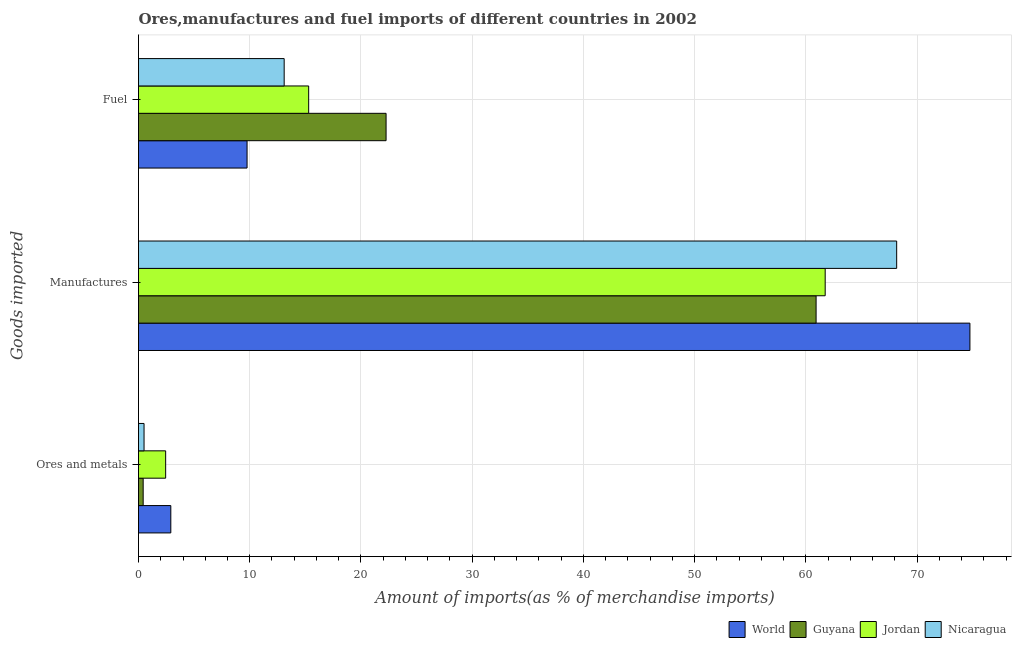How many different coloured bars are there?
Give a very brief answer. 4. How many groups of bars are there?
Your response must be concise. 3. Are the number of bars on each tick of the Y-axis equal?
Provide a short and direct response. Yes. How many bars are there on the 1st tick from the top?
Your answer should be compact. 4. What is the label of the 2nd group of bars from the top?
Give a very brief answer. Manufactures. What is the percentage of fuel imports in Guyana?
Your response must be concise. 22.26. Across all countries, what is the maximum percentage of fuel imports?
Make the answer very short. 22.26. Across all countries, what is the minimum percentage of ores and metals imports?
Provide a succinct answer. 0.42. In which country was the percentage of fuel imports maximum?
Offer a terse response. Guyana. In which country was the percentage of ores and metals imports minimum?
Ensure brevity in your answer.  Guyana. What is the total percentage of manufactures imports in the graph?
Make the answer very short. 265.57. What is the difference between the percentage of fuel imports in Jordan and that in Guyana?
Provide a succinct answer. -6.96. What is the difference between the percentage of ores and metals imports in Jordan and the percentage of manufactures imports in Nicaragua?
Provide a short and direct response. -65.72. What is the average percentage of ores and metals imports per country?
Your answer should be very brief. 1.57. What is the difference between the percentage of manufactures imports and percentage of ores and metals imports in World?
Make the answer very short. 71.85. What is the ratio of the percentage of fuel imports in Nicaragua to that in Jordan?
Provide a short and direct response. 0.86. Is the difference between the percentage of ores and metals imports in World and Guyana greater than the difference between the percentage of fuel imports in World and Guyana?
Provide a succinct answer. Yes. What is the difference between the highest and the second highest percentage of manufactures imports?
Provide a succinct answer. 6.59. What is the difference between the highest and the lowest percentage of manufactures imports?
Make the answer very short. 13.83. Is the sum of the percentage of fuel imports in World and Guyana greater than the maximum percentage of ores and metals imports across all countries?
Make the answer very short. Yes. What does the 2nd bar from the top in Ores and metals represents?
Your answer should be very brief. Jordan. What does the 3rd bar from the bottom in Manufactures represents?
Give a very brief answer. Jordan. Does the graph contain any zero values?
Make the answer very short. No. Does the graph contain grids?
Keep it short and to the point. Yes. Where does the legend appear in the graph?
Your response must be concise. Bottom right. How many legend labels are there?
Your answer should be very brief. 4. How are the legend labels stacked?
Your answer should be compact. Horizontal. What is the title of the graph?
Offer a very short reply. Ores,manufactures and fuel imports of different countries in 2002. Does "Timor-Leste" appear as one of the legend labels in the graph?
Your response must be concise. No. What is the label or title of the X-axis?
Provide a short and direct response. Amount of imports(as % of merchandise imports). What is the label or title of the Y-axis?
Your answer should be very brief. Goods imported. What is the Amount of imports(as % of merchandise imports) in World in Ores and metals?
Give a very brief answer. 2.9. What is the Amount of imports(as % of merchandise imports) of Guyana in Ores and metals?
Your answer should be very brief. 0.42. What is the Amount of imports(as % of merchandise imports) in Jordan in Ores and metals?
Ensure brevity in your answer.  2.44. What is the Amount of imports(as % of merchandise imports) of Nicaragua in Ores and metals?
Ensure brevity in your answer.  0.5. What is the Amount of imports(as % of merchandise imports) in World in Manufactures?
Give a very brief answer. 74.75. What is the Amount of imports(as % of merchandise imports) of Guyana in Manufactures?
Provide a succinct answer. 60.92. What is the Amount of imports(as % of merchandise imports) of Jordan in Manufactures?
Ensure brevity in your answer.  61.74. What is the Amount of imports(as % of merchandise imports) in Nicaragua in Manufactures?
Make the answer very short. 68.16. What is the Amount of imports(as % of merchandise imports) in World in Fuel?
Keep it short and to the point. 9.76. What is the Amount of imports(as % of merchandise imports) in Guyana in Fuel?
Keep it short and to the point. 22.26. What is the Amount of imports(as % of merchandise imports) of Jordan in Fuel?
Offer a very short reply. 15.3. What is the Amount of imports(as % of merchandise imports) in Nicaragua in Fuel?
Offer a very short reply. 13.1. Across all Goods imported, what is the maximum Amount of imports(as % of merchandise imports) in World?
Make the answer very short. 74.75. Across all Goods imported, what is the maximum Amount of imports(as % of merchandise imports) of Guyana?
Give a very brief answer. 60.92. Across all Goods imported, what is the maximum Amount of imports(as % of merchandise imports) in Jordan?
Offer a terse response. 61.74. Across all Goods imported, what is the maximum Amount of imports(as % of merchandise imports) in Nicaragua?
Your answer should be compact. 68.16. Across all Goods imported, what is the minimum Amount of imports(as % of merchandise imports) in World?
Keep it short and to the point. 2.9. Across all Goods imported, what is the minimum Amount of imports(as % of merchandise imports) of Guyana?
Provide a short and direct response. 0.42. Across all Goods imported, what is the minimum Amount of imports(as % of merchandise imports) of Jordan?
Offer a very short reply. 2.44. Across all Goods imported, what is the minimum Amount of imports(as % of merchandise imports) of Nicaragua?
Keep it short and to the point. 0.5. What is the total Amount of imports(as % of merchandise imports) of World in the graph?
Provide a short and direct response. 87.42. What is the total Amount of imports(as % of merchandise imports) of Guyana in the graph?
Give a very brief answer. 83.6. What is the total Amount of imports(as % of merchandise imports) of Jordan in the graph?
Your answer should be compact. 79.48. What is the total Amount of imports(as % of merchandise imports) of Nicaragua in the graph?
Your answer should be compact. 81.76. What is the difference between the Amount of imports(as % of merchandise imports) of World in Ores and metals and that in Manufactures?
Your answer should be compact. -71.85. What is the difference between the Amount of imports(as % of merchandise imports) of Guyana in Ores and metals and that in Manufactures?
Offer a terse response. -60.5. What is the difference between the Amount of imports(as % of merchandise imports) of Jordan in Ores and metals and that in Manufactures?
Offer a terse response. -59.3. What is the difference between the Amount of imports(as % of merchandise imports) in Nicaragua in Ores and metals and that in Manufactures?
Provide a short and direct response. -67.67. What is the difference between the Amount of imports(as % of merchandise imports) of World in Ores and metals and that in Fuel?
Keep it short and to the point. -6.86. What is the difference between the Amount of imports(as % of merchandise imports) of Guyana in Ores and metals and that in Fuel?
Ensure brevity in your answer.  -21.84. What is the difference between the Amount of imports(as % of merchandise imports) in Jordan in Ores and metals and that in Fuel?
Ensure brevity in your answer.  -12.86. What is the difference between the Amount of imports(as % of merchandise imports) of Nicaragua in Ores and metals and that in Fuel?
Offer a very short reply. -12.6. What is the difference between the Amount of imports(as % of merchandise imports) in World in Manufactures and that in Fuel?
Your response must be concise. 64.99. What is the difference between the Amount of imports(as % of merchandise imports) in Guyana in Manufactures and that in Fuel?
Offer a terse response. 38.66. What is the difference between the Amount of imports(as % of merchandise imports) in Jordan in Manufactures and that in Fuel?
Give a very brief answer. 46.44. What is the difference between the Amount of imports(as % of merchandise imports) of Nicaragua in Manufactures and that in Fuel?
Offer a very short reply. 55.07. What is the difference between the Amount of imports(as % of merchandise imports) in World in Ores and metals and the Amount of imports(as % of merchandise imports) in Guyana in Manufactures?
Provide a short and direct response. -58.02. What is the difference between the Amount of imports(as % of merchandise imports) in World in Ores and metals and the Amount of imports(as % of merchandise imports) in Jordan in Manufactures?
Your response must be concise. -58.83. What is the difference between the Amount of imports(as % of merchandise imports) of World in Ores and metals and the Amount of imports(as % of merchandise imports) of Nicaragua in Manufactures?
Your answer should be compact. -65.26. What is the difference between the Amount of imports(as % of merchandise imports) of Guyana in Ores and metals and the Amount of imports(as % of merchandise imports) of Jordan in Manufactures?
Offer a very short reply. -61.32. What is the difference between the Amount of imports(as % of merchandise imports) of Guyana in Ores and metals and the Amount of imports(as % of merchandise imports) of Nicaragua in Manufactures?
Provide a succinct answer. -67.75. What is the difference between the Amount of imports(as % of merchandise imports) of Jordan in Ores and metals and the Amount of imports(as % of merchandise imports) of Nicaragua in Manufactures?
Give a very brief answer. -65.72. What is the difference between the Amount of imports(as % of merchandise imports) of World in Ores and metals and the Amount of imports(as % of merchandise imports) of Guyana in Fuel?
Provide a short and direct response. -19.35. What is the difference between the Amount of imports(as % of merchandise imports) in World in Ores and metals and the Amount of imports(as % of merchandise imports) in Jordan in Fuel?
Offer a very short reply. -12.39. What is the difference between the Amount of imports(as % of merchandise imports) in World in Ores and metals and the Amount of imports(as % of merchandise imports) in Nicaragua in Fuel?
Offer a terse response. -10.19. What is the difference between the Amount of imports(as % of merchandise imports) in Guyana in Ores and metals and the Amount of imports(as % of merchandise imports) in Jordan in Fuel?
Provide a succinct answer. -14.88. What is the difference between the Amount of imports(as % of merchandise imports) of Guyana in Ores and metals and the Amount of imports(as % of merchandise imports) of Nicaragua in Fuel?
Your response must be concise. -12.68. What is the difference between the Amount of imports(as % of merchandise imports) of Jordan in Ores and metals and the Amount of imports(as % of merchandise imports) of Nicaragua in Fuel?
Provide a short and direct response. -10.66. What is the difference between the Amount of imports(as % of merchandise imports) of World in Manufactures and the Amount of imports(as % of merchandise imports) of Guyana in Fuel?
Provide a succinct answer. 52.49. What is the difference between the Amount of imports(as % of merchandise imports) in World in Manufactures and the Amount of imports(as % of merchandise imports) in Jordan in Fuel?
Provide a short and direct response. 59.45. What is the difference between the Amount of imports(as % of merchandise imports) of World in Manufactures and the Amount of imports(as % of merchandise imports) of Nicaragua in Fuel?
Your answer should be very brief. 61.65. What is the difference between the Amount of imports(as % of merchandise imports) in Guyana in Manufactures and the Amount of imports(as % of merchandise imports) in Jordan in Fuel?
Offer a very short reply. 45.62. What is the difference between the Amount of imports(as % of merchandise imports) of Guyana in Manufactures and the Amount of imports(as % of merchandise imports) of Nicaragua in Fuel?
Offer a very short reply. 47.82. What is the difference between the Amount of imports(as % of merchandise imports) of Jordan in Manufactures and the Amount of imports(as % of merchandise imports) of Nicaragua in Fuel?
Offer a very short reply. 48.64. What is the average Amount of imports(as % of merchandise imports) in World per Goods imported?
Your answer should be compact. 29.14. What is the average Amount of imports(as % of merchandise imports) of Guyana per Goods imported?
Offer a very short reply. 27.87. What is the average Amount of imports(as % of merchandise imports) in Jordan per Goods imported?
Provide a short and direct response. 26.49. What is the average Amount of imports(as % of merchandise imports) in Nicaragua per Goods imported?
Offer a very short reply. 27.25. What is the difference between the Amount of imports(as % of merchandise imports) of World and Amount of imports(as % of merchandise imports) of Guyana in Ores and metals?
Keep it short and to the point. 2.49. What is the difference between the Amount of imports(as % of merchandise imports) in World and Amount of imports(as % of merchandise imports) in Jordan in Ores and metals?
Provide a succinct answer. 0.46. What is the difference between the Amount of imports(as % of merchandise imports) of World and Amount of imports(as % of merchandise imports) of Nicaragua in Ores and metals?
Provide a succinct answer. 2.41. What is the difference between the Amount of imports(as % of merchandise imports) in Guyana and Amount of imports(as % of merchandise imports) in Jordan in Ores and metals?
Your answer should be very brief. -2.02. What is the difference between the Amount of imports(as % of merchandise imports) in Guyana and Amount of imports(as % of merchandise imports) in Nicaragua in Ores and metals?
Provide a short and direct response. -0.08. What is the difference between the Amount of imports(as % of merchandise imports) of Jordan and Amount of imports(as % of merchandise imports) of Nicaragua in Ores and metals?
Offer a very short reply. 1.94. What is the difference between the Amount of imports(as % of merchandise imports) of World and Amount of imports(as % of merchandise imports) of Guyana in Manufactures?
Make the answer very short. 13.83. What is the difference between the Amount of imports(as % of merchandise imports) in World and Amount of imports(as % of merchandise imports) in Jordan in Manufactures?
Keep it short and to the point. 13.01. What is the difference between the Amount of imports(as % of merchandise imports) in World and Amount of imports(as % of merchandise imports) in Nicaragua in Manufactures?
Offer a very short reply. 6.59. What is the difference between the Amount of imports(as % of merchandise imports) of Guyana and Amount of imports(as % of merchandise imports) of Jordan in Manufactures?
Provide a short and direct response. -0.82. What is the difference between the Amount of imports(as % of merchandise imports) in Guyana and Amount of imports(as % of merchandise imports) in Nicaragua in Manufactures?
Provide a succinct answer. -7.24. What is the difference between the Amount of imports(as % of merchandise imports) in Jordan and Amount of imports(as % of merchandise imports) in Nicaragua in Manufactures?
Give a very brief answer. -6.43. What is the difference between the Amount of imports(as % of merchandise imports) of World and Amount of imports(as % of merchandise imports) of Guyana in Fuel?
Keep it short and to the point. -12.5. What is the difference between the Amount of imports(as % of merchandise imports) in World and Amount of imports(as % of merchandise imports) in Jordan in Fuel?
Offer a terse response. -5.54. What is the difference between the Amount of imports(as % of merchandise imports) in World and Amount of imports(as % of merchandise imports) in Nicaragua in Fuel?
Your answer should be compact. -3.34. What is the difference between the Amount of imports(as % of merchandise imports) in Guyana and Amount of imports(as % of merchandise imports) in Jordan in Fuel?
Your answer should be very brief. 6.96. What is the difference between the Amount of imports(as % of merchandise imports) in Guyana and Amount of imports(as % of merchandise imports) in Nicaragua in Fuel?
Ensure brevity in your answer.  9.16. What is the difference between the Amount of imports(as % of merchandise imports) of Jordan and Amount of imports(as % of merchandise imports) of Nicaragua in Fuel?
Give a very brief answer. 2.2. What is the ratio of the Amount of imports(as % of merchandise imports) in World in Ores and metals to that in Manufactures?
Your response must be concise. 0.04. What is the ratio of the Amount of imports(as % of merchandise imports) in Guyana in Ores and metals to that in Manufactures?
Make the answer very short. 0.01. What is the ratio of the Amount of imports(as % of merchandise imports) in Jordan in Ores and metals to that in Manufactures?
Your answer should be compact. 0.04. What is the ratio of the Amount of imports(as % of merchandise imports) in Nicaragua in Ores and metals to that in Manufactures?
Make the answer very short. 0.01. What is the ratio of the Amount of imports(as % of merchandise imports) in World in Ores and metals to that in Fuel?
Your response must be concise. 0.3. What is the ratio of the Amount of imports(as % of merchandise imports) in Guyana in Ores and metals to that in Fuel?
Your response must be concise. 0.02. What is the ratio of the Amount of imports(as % of merchandise imports) in Jordan in Ores and metals to that in Fuel?
Your answer should be very brief. 0.16. What is the ratio of the Amount of imports(as % of merchandise imports) in Nicaragua in Ores and metals to that in Fuel?
Your answer should be very brief. 0.04. What is the ratio of the Amount of imports(as % of merchandise imports) in World in Manufactures to that in Fuel?
Your response must be concise. 7.66. What is the ratio of the Amount of imports(as % of merchandise imports) of Guyana in Manufactures to that in Fuel?
Make the answer very short. 2.74. What is the ratio of the Amount of imports(as % of merchandise imports) in Jordan in Manufactures to that in Fuel?
Provide a succinct answer. 4.04. What is the ratio of the Amount of imports(as % of merchandise imports) of Nicaragua in Manufactures to that in Fuel?
Offer a terse response. 5.2. What is the difference between the highest and the second highest Amount of imports(as % of merchandise imports) in World?
Offer a terse response. 64.99. What is the difference between the highest and the second highest Amount of imports(as % of merchandise imports) in Guyana?
Give a very brief answer. 38.66. What is the difference between the highest and the second highest Amount of imports(as % of merchandise imports) of Jordan?
Offer a terse response. 46.44. What is the difference between the highest and the second highest Amount of imports(as % of merchandise imports) of Nicaragua?
Ensure brevity in your answer.  55.07. What is the difference between the highest and the lowest Amount of imports(as % of merchandise imports) in World?
Ensure brevity in your answer.  71.85. What is the difference between the highest and the lowest Amount of imports(as % of merchandise imports) of Guyana?
Your answer should be compact. 60.5. What is the difference between the highest and the lowest Amount of imports(as % of merchandise imports) of Jordan?
Your answer should be compact. 59.3. What is the difference between the highest and the lowest Amount of imports(as % of merchandise imports) in Nicaragua?
Keep it short and to the point. 67.67. 